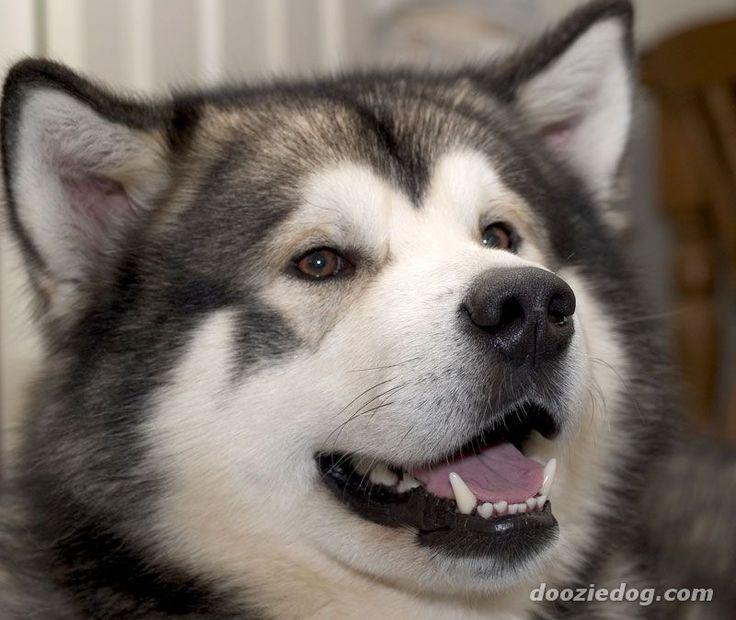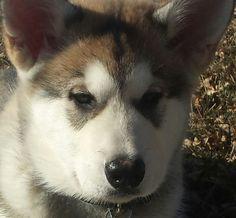The first image is the image on the left, the second image is the image on the right. Evaluate the accuracy of this statement regarding the images: "One image shows a gray-and-white husky puppy sitting upright, and the other image shows a darker adult husky with its mouth open.". Is it true? Answer yes or no. No. 